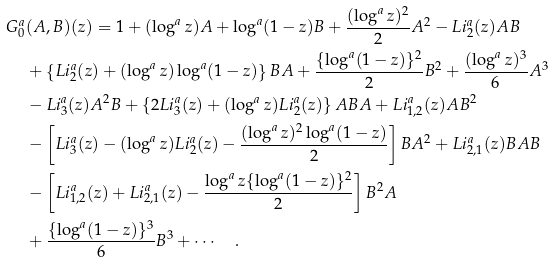Convert formula to latex. <formula><loc_0><loc_0><loc_500><loc_500>G ^ { a } _ { 0 } & ( A , B ) ( z ) = 1 + ( \log ^ { a } z ) A + { \log ^ { a } ( 1 - z ) } B + \frac { ( \log ^ { a } z ) ^ { 2 } } { 2 } A ^ { 2 } - L i ^ { a } _ { 2 } ( z ) A B \\ & + \left \{ L i ^ { a } _ { 2 } ( z ) + ( \log ^ { a } z ) \log ^ { a } ( 1 - z ) \right \} B A + \frac { \{ \log ^ { a } ( 1 - z ) \} ^ { 2 } } { 2 } B ^ { 2 } + \frac { ( \log ^ { a } z ) ^ { 3 } } { 6 } A ^ { 3 } \\ & - L i ^ { a } _ { 3 } ( z ) A ^ { 2 } B + \left \{ 2 L i ^ { a } _ { 3 } ( z ) + ( \log ^ { a } z ) L i ^ { a } _ { 2 } ( z ) \right \} A B A + L i ^ { a } _ { 1 , 2 } ( z ) A B ^ { 2 } \\ & - \left [ L i ^ { a } _ { 3 } ( z ) - ( \log ^ { a } z ) L i ^ { a } _ { 2 } ( z ) - \frac { ( \log ^ { a } z ) ^ { 2 } \log ^ { a } ( 1 - z ) } { 2 } \right ] B A ^ { 2 } + L i ^ { a } _ { 2 , 1 } ( z ) B A B \\ & - \left [ L i ^ { a } _ { 1 , 2 } ( z ) + L i ^ { a } _ { 2 , 1 } ( z ) - \frac { \log ^ { a } z \{ \log ^ { a } ( 1 - z ) \} ^ { 2 } } { 2 } \right ] B ^ { 2 } A \\ & + \frac { \{ \log ^ { a } ( 1 - z ) \} ^ { 3 } } { 6 } B ^ { 3 } + \cdots \quad . \\</formula> 